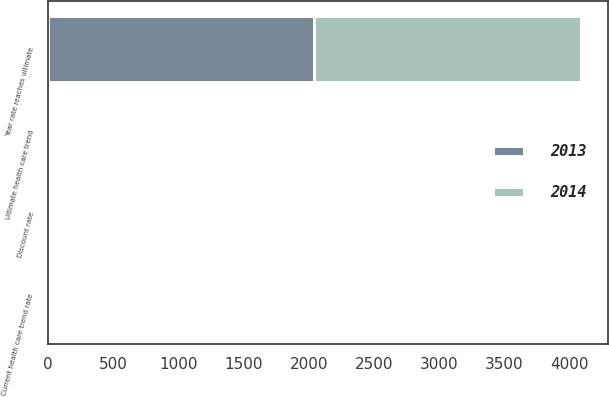Convert chart to OTSL. <chart><loc_0><loc_0><loc_500><loc_500><stacked_bar_chart><ecel><fcel>Discount rate<fcel>Current health care trend rate<fcel>Ultimate health care trend<fcel>Year rate reaches ultimate<nl><fcel>2013<fcel>3.6<fcel>8<fcel>5<fcel>2042<nl><fcel>2014<fcel>4.25<fcel>8<fcel>5<fcel>2045<nl></chart> 